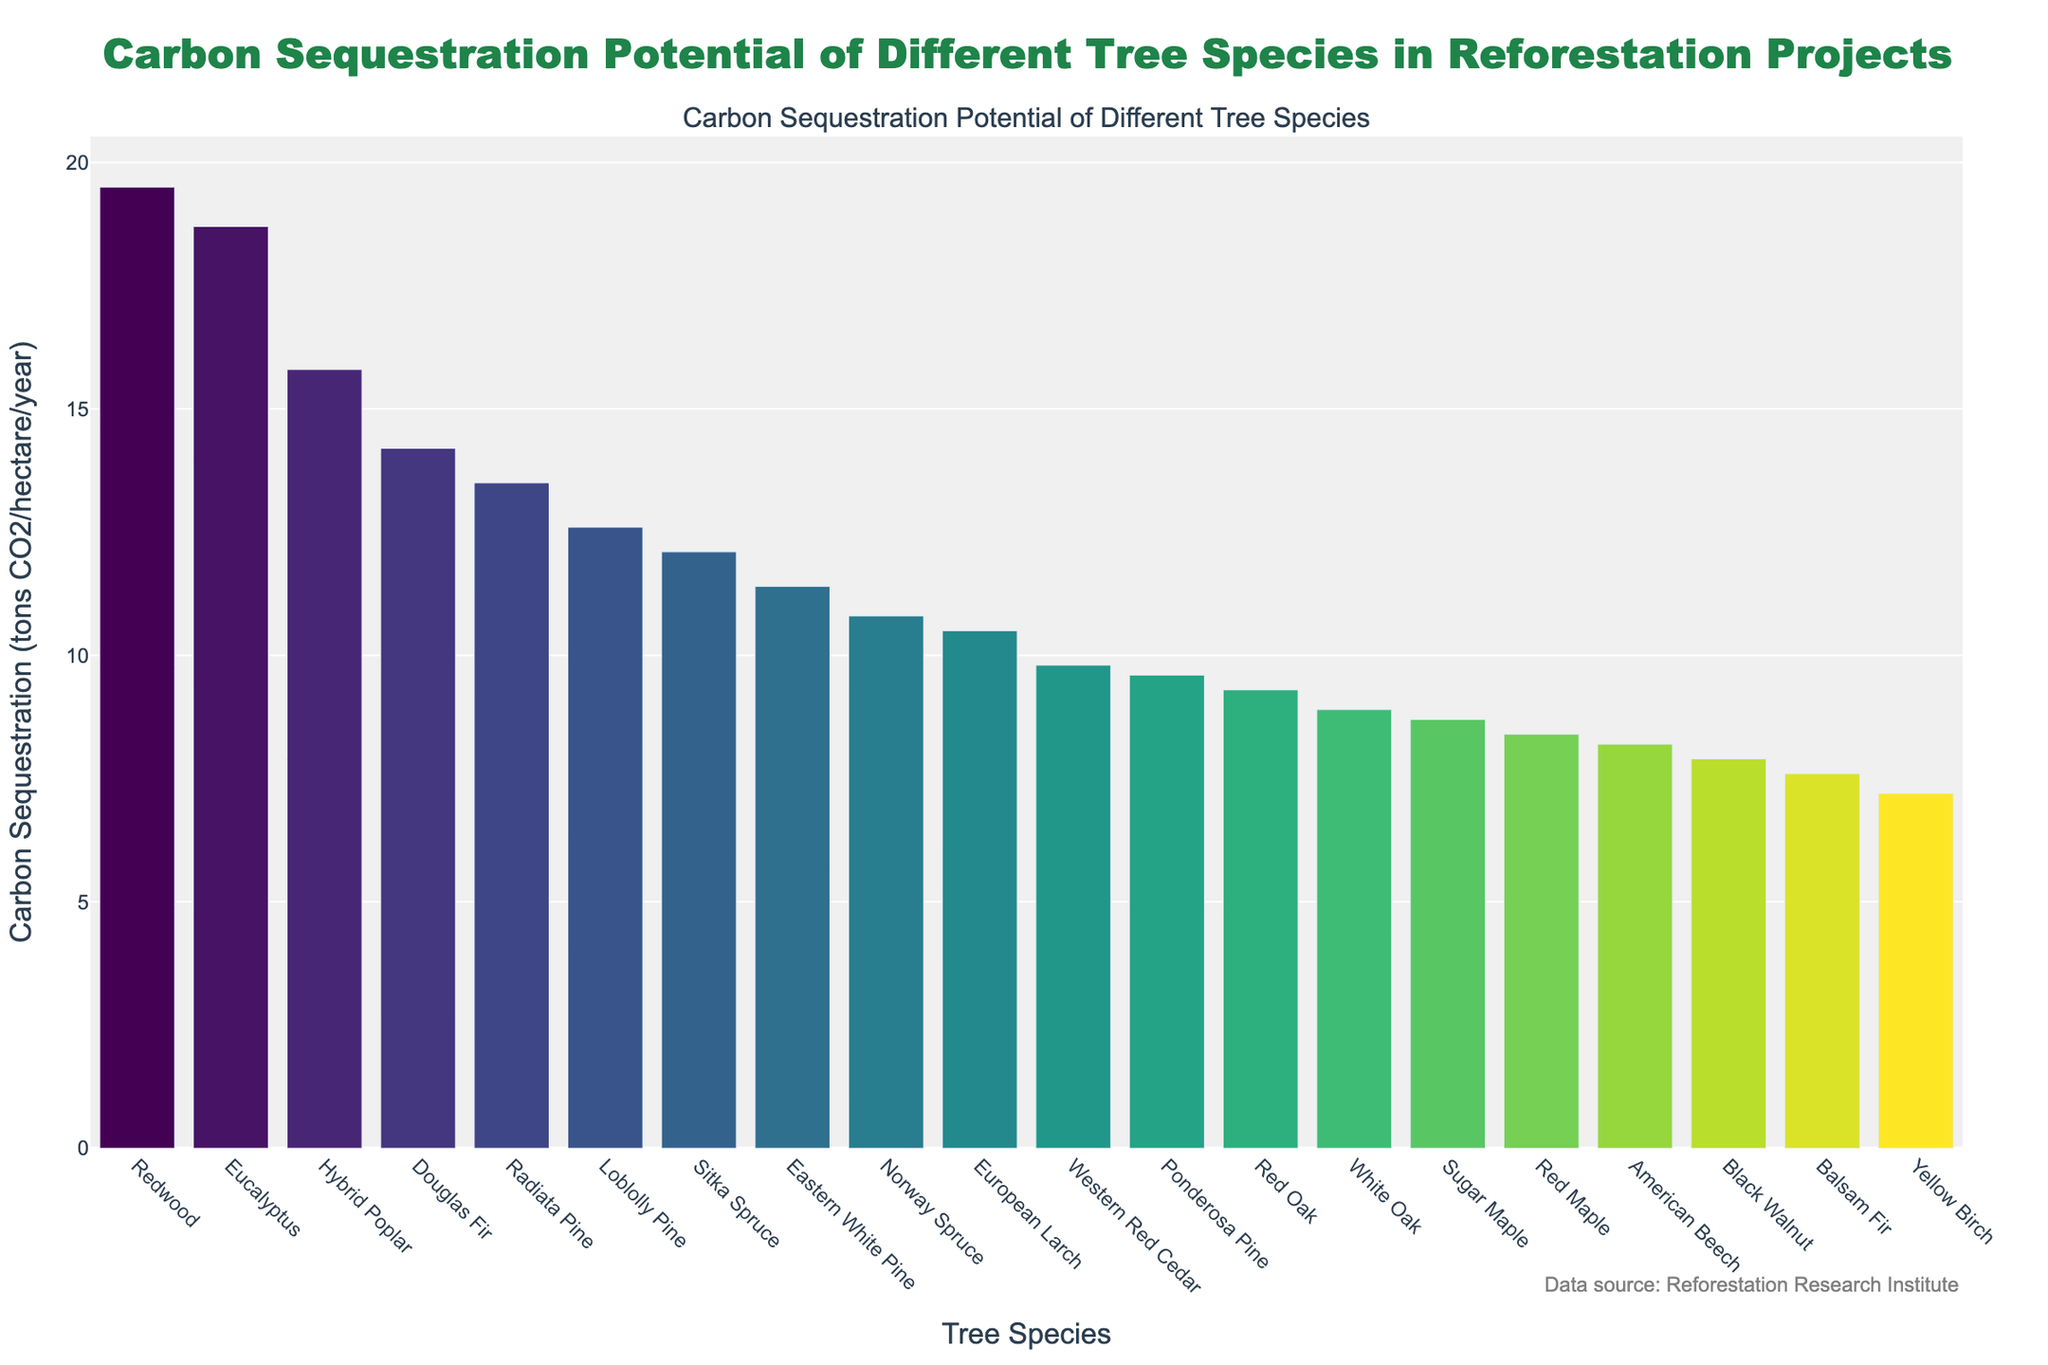What is the tree species with the highest carbon sequestration potential? Look at the bar chart and identify the bar with the greatest height, which corresponds to the highest carbon sequestration value. In this case, the Redwood tree has the highest bar at 19.5 tons CO2/hectare/year.
Answer: Redwood Which tree species has the lowest carbon sequestration potential? Identify the bar in the chart with the shortest height. The Yellow Birch tree's bar is the shortest, indicating a carbon sequestration potential of 7.2 tons CO2/hectare/year.
Answer: Yellow Birch How much more carbon dioxide does Redwood sequester compared to Black Walnut per hectare per year? Find the bar heights for both Redwood and Black Walnut. Redwood sequesters 19.5 tons CO2/hectare/year, and Black Walnut sequesters 7.9 tons CO2/hectare/year. Subtract the two values: 19.5 - 7.9 = 11.6 tons of CO2/hectare/year.
Answer: 11.6 tons CO2/hectare/year Which tree species sequester more than 10 tons CO2/hectare/year? Look at the bars exceeding the height representing 10 tons CO2/hectare/year. The species are Douglas Fir, Eucalyptus, Radiata Pine, Loblolly Pine, Eastern White Pine, Sitka Spruce, Hybrid Poplar, Redwood, and Norway Spruce.
Answer: Douglas Fir, Eucalyptus, Radiata Pine, Loblolly Pine, Eastern White Pine, Sitka Spruce, Hybrid Poplar, Redwood, Norway Spruce What is the average carbon sequestration potential of all tree species? Sum the carbon sequestration values for all species and divide by the number of species. The sum is 14.2 + 18.7 + 13.5 + 10.8 + 12.6 + 9.3 + 8.7 + 11.4 + 19.5 + 12.1 + 9.8 + 7.9 + 8.2 + 10.5 + 9.6 + 8.9 + 7.6 + 15.8 + 8.4 + 7.2 = 224.7. There are 20 tree species. 224.7 / 20 = 11.2 tons CO2/hectare/year.
Answer: 11.2 tons CO2/hectare/year How does the carbon sequestration potential of Eucalyptus compare to that of Hybrid Poplar? Check the heights of the bars for Eucalyptus and Hybrid Poplar. Eucalyptus sequesters 18.7 tons CO2/hectare/year, and Hybrid Poplar sequesters 15.8 tons CO2/hectare/year. Eucalyptus has a higher sequestration potential.
Answer: Eucalyptus sequesters more Which tree species have sequestration potentials closest to 10 tons CO2/hectare/year, and what are their exact values? Identify the bars around 10 tons CO2/hectare/year and list their values. The species are Norway Spruce (10.8), European Larch (10.5), and Western Red Cedar (9.8).
Answer: Norway Spruce (10.8), European Larch (10.5), Western Red Cedar (9.8) What's the combined carbon sequestration potential of the top three tree species? Identify the top three highest bars: Redwood (19.5), Eucalyptus (18.7), and Hybrid Poplar (15.8). Sum their values: 19.5 + 18.7 + 15.8 = 54 tons CO2/hectare/year.
Answer: 54 tons CO2/hectare/year What is the difference between the carbon sequestration potentials of Radiata Pine and Ponderosa Pine? Find the bar heights for Radiata Pine (13.5) and Ponderosa Pine (9.6). Subtract the two values: 13.5 - 9.6 = 3.9 tons CO2/hectare/year.
Answer: 3.9 tons CO2/hectare/year Which color shades are used to represent the bars, and what might be the reasoning behind this color choice? The bars use shades of a color gradient (likely from the Viridis color scale), starting from dark green to light yellow-green. This visually represents the varying magnitudes of carbon sequestration potential, aiding intuitive comparisons between tree species.
Answer: Gradient from dark green to light yellow-green 